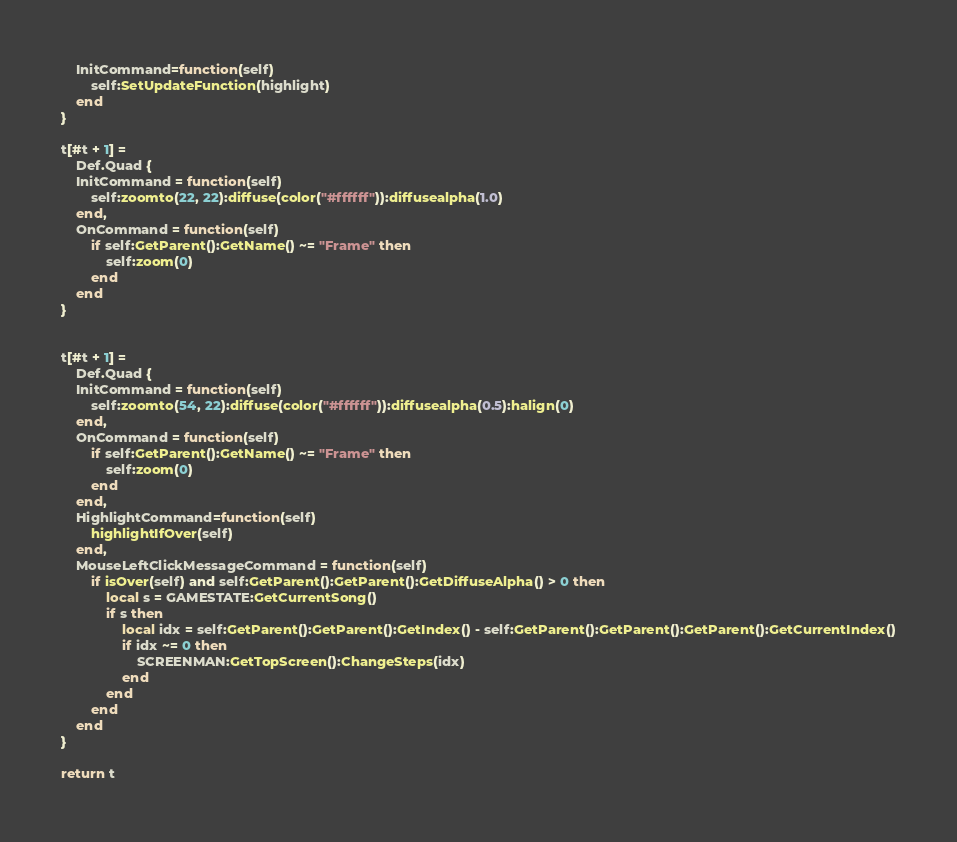Convert code to text. <code><loc_0><loc_0><loc_500><loc_500><_Lua_>	InitCommand=function(self)
		self:SetUpdateFunction(highlight)
	end
}

t[#t + 1] =
	Def.Quad {
	InitCommand = function(self)
		self:zoomto(22, 22):diffuse(color("#ffffff")):diffusealpha(1.0)
	end,
	OnCommand = function(self)
		if self:GetParent():GetName() ~= "Frame" then
			self:zoom(0)
		end
	end
}


t[#t + 1] =
	Def.Quad {
	InitCommand = function(self)
		self:zoomto(54, 22):diffuse(color("#ffffff")):diffusealpha(0.5):halign(0)
	end,
	OnCommand = function(self)
		if self:GetParent():GetName() ~= "Frame" then
			self:zoom(0)
		end
	end,
	HighlightCommand=function(self)
		highlightIfOver(self)
	end,
	MouseLeftClickMessageCommand = function(self)
		if isOver(self) and self:GetParent():GetParent():GetDiffuseAlpha() > 0 then
			local s = GAMESTATE:GetCurrentSong()
			if s then
				local idx = self:GetParent():GetParent():GetIndex() - self:GetParent():GetParent():GetParent():GetCurrentIndex()
				if idx ~= 0 then
					SCREENMAN:GetTopScreen():ChangeSteps(idx)
				end
			end
		end
	end
}

return t
</code> 